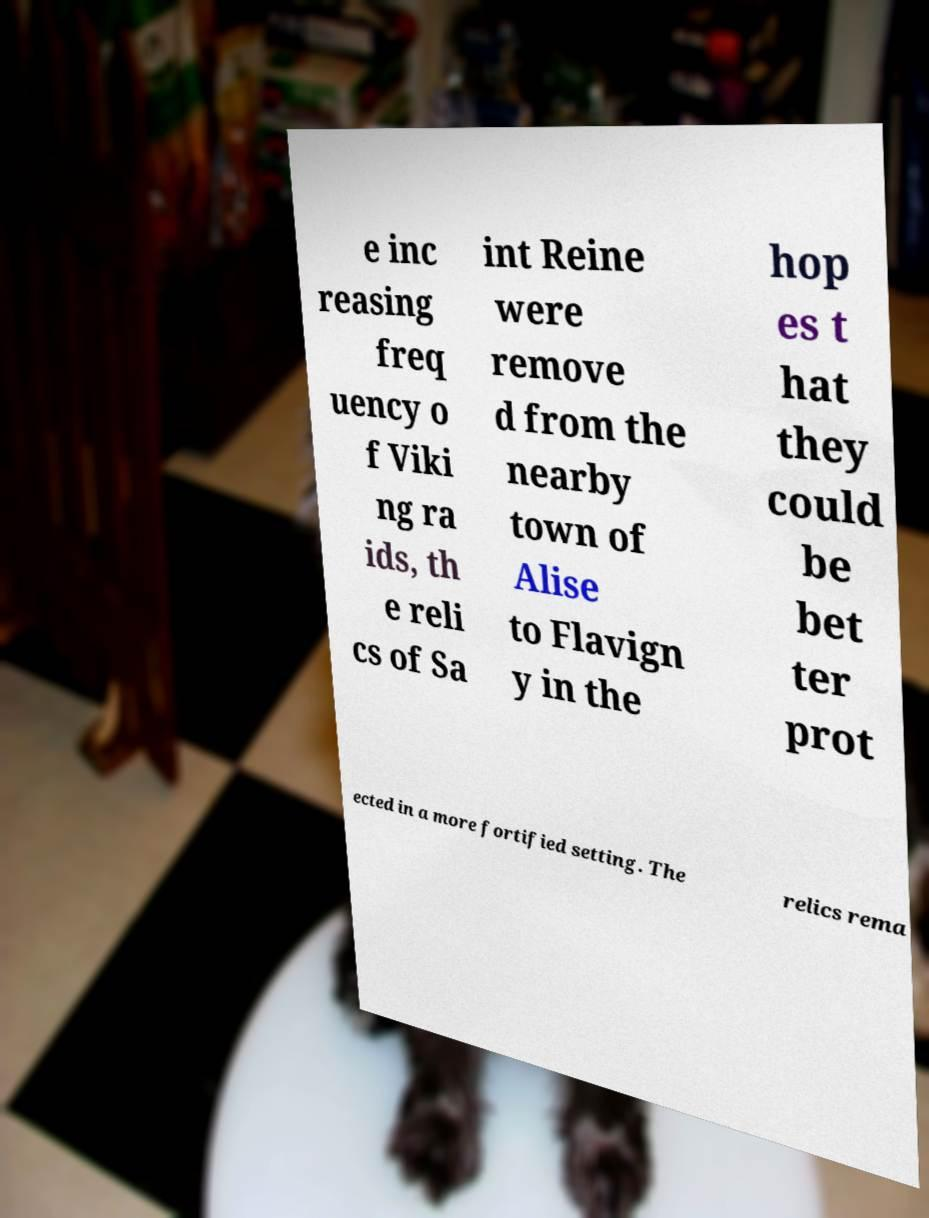Could you extract and type out the text from this image? e inc reasing freq uency o f Viki ng ra ids, th e reli cs of Sa int Reine were remove d from the nearby town of Alise to Flavign y in the hop es t hat they could be bet ter prot ected in a more fortified setting. The relics rema 